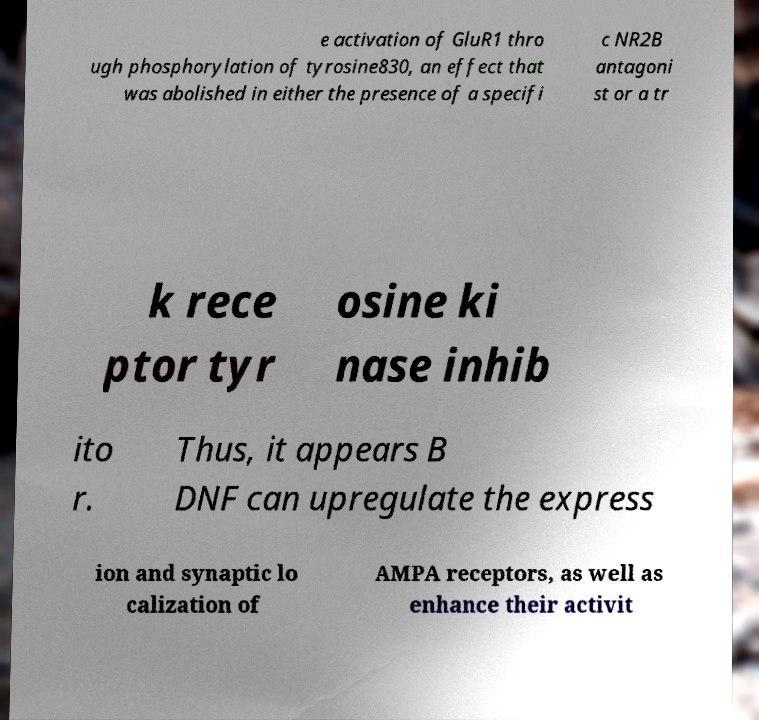I need the written content from this picture converted into text. Can you do that? e activation of GluR1 thro ugh phosphorylation of tyrosine830, an effect that was abolished in either the presence of a specifi c NR2B antagoni st or a tr k rece ptor tyr osine ki nase inhib ito r. Thus, it appears B DNF can upregulate the express ion and synaptic lo calization of AMPA receptors, as well as enhance their activit 